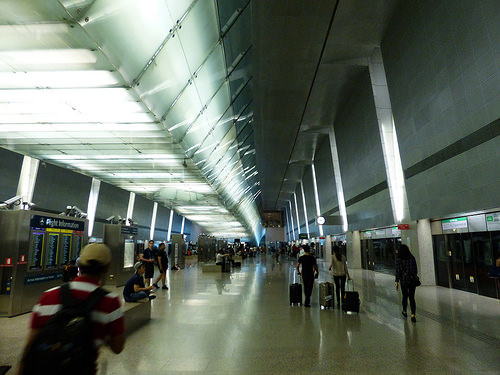<image>
Is the bag on the man? Yes. Looking at the image, I can see the bag is positioned on top of the man, with the man providing support. 